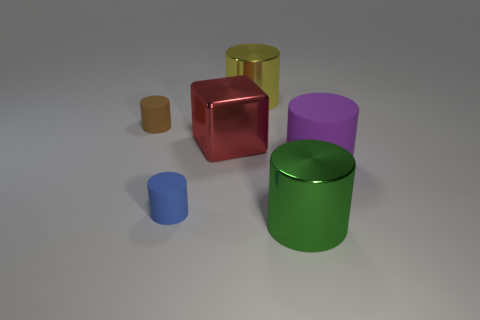Is there any other thing that is the same shape as the red shiny object?
Your answer should be very brief. No. What number of other things are made of the same material as the purple thing?
Your answer should be very brief. 2. What shape is the large thing on the left side of the metallic cylinder that is behind the big metallic object to the right of the yellow metallic thing?
Make the answer very short. Cube. Are there fewer yellow cylinders in front of the red thing than large cubes that are in front of the large green shiny cylinder?
Your answer should be very brief. No. Do the yellow thing and the big cylinder in front of the large purple rubber object have the same material?
Offer a terse response. Yes. Are there any blue rubber cylinders that are to the right of the big thing right of the green thing?
Keep it short and to the point. No. What color is the cylinder that is both to the left of the green metallic object and to the right of the cube?
Keep it short and to the point. Yellow. The green shiny cylinder has what size?
Offer a very short reply. Large. What number of green objects have the same size as the red metallic object?
Keep it short and to the point. 1. Does the big cylinder left of the big green metallic thing have the same material as the cylinder right of the green metallic thing?
Make the answer very short. No. 